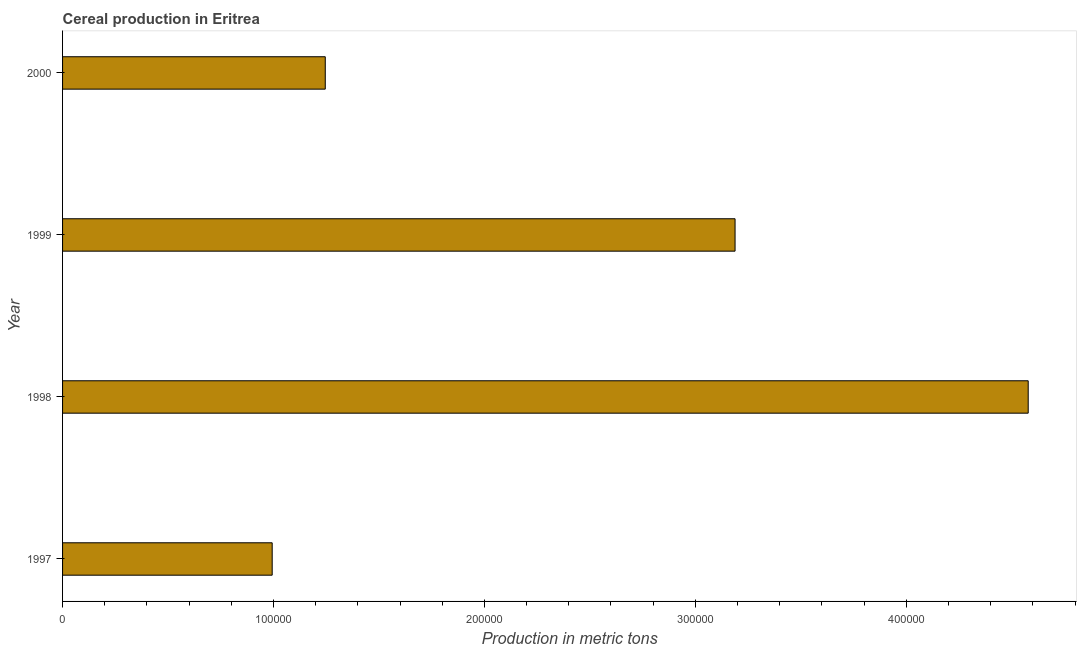Does the graph contain any zero values?
Your answer should be compact. No. Does the graph contain grids?
Offer a terse response. No. What is the title of the graph?
Offer a terse response. Cereal production in Eritrea. What is the label or title of the X-axis?
Provide a short and direct response. Production in metric tons. What is the cereal production in 1998?
Provide a succinct answer. 4.58e+05. Across all years, what is the maximum cereal production?
Your answer should be compact. 4.58e+05. Across all years, what is the minimum cereal production?
Keep it short and to the point. 9.94e+04. In which year was the cereal production maximum?
Your response must be concise. 1998. In which year was the cereal production minimum?
Provide a short and direct response. 1997. What is the sum of the cereal production?
Ensure brevity in your answer.  1.00e+06. What is the difference between the cereal production in 1997 and 1998?
Your answer should be compact. -3.58e+05. What is the average cereal production per year?
Provide a succinct answer. 2.50e+05. What is the median cereal production?
Offer a very short reply. 2.22e+05. What is the ratio of the cereal production in 1997 to that in 1998?
Offer a very short reply. 0.22. Is the difference between the cereal production in 1998 and 1999 greater than the difference between any two years?
Offer a terse response. No. What is the difference between the highest and the second highest cereal production?
Make the answer very short. 1.39e+05. What is the difference between the highest and the lowest cereal production?
Your answer should be compact. 3.58e+05. In how many years, is the cereal production greater than the average cereal production taken over all years?
Ensure brevity in your answer.  2. How many bars are there?
Provide a short and direct response. 4. Are all the bars in the graph horizontal?
Offer a very short reply. Yes. What is the difference between two consecutive major ticks on the X-axis?
Make the answer very short. 1.00e+05. Are the values on the major ticks of X-axis written in scientific E-notation?
Ensure brevity in your answer.  No. What is the Production in metric tons in 1997?
Offer a very short reply. 9.94e+04. What is the Production in metric tons in 1998?
Offer a very short reply. 4.58e+05. What is the Production in metric tons of 1999?
Give a very brief answer. 3.19e+05. What is the Production in metric tons in 2000?
Ensure brevity in your answer.  1.25e+05. What is the difference between the Production in metric tons in 1997 and 1998?
Give a very brief answer. -3.58e+05. What is the difference between the Production in metric tons in 1997 and 1999?
Your answer should be very brief. -2.19e+05. What is the difference between the Production in metric tons in 1997 and 2000?
Your response must be concise. -2.52e+04. What is the difference between the Production in metric tons in 1998 and 1999?
Make the answer very short. 1.39e+05. What is the difference between the Production in metric tons in 1998 and 2000?
Give a very brief answer. 3.33e+05. What is the difference between the Production in metric tons in 1999 and 2000?
Your answer should be very brief. 1.94e+05. What is the ratio of the Production in metric tons in 1997 to that in 1998?
Your response must be concise. 0.22. What is the ratio of the Production in metric tons in 1997 to that in 1999?
Keep it short and to the point. 0.31. What is the ratio of the Production in metric tons in 1997 to that in 2000?
Offer a very short reply. 0.8. What is the ratio of the Production in metric tons in 1998 to that in 1999?
Your answer should be compact. 1.44. What is the ratio of the Production in metric tons in 1998 to that in 2000?
Provide a short and direct response. 3.68. What is the ratio of the Production in metric tons in 1999 to that in 2000?
Your answer should be compact. 2.56. 